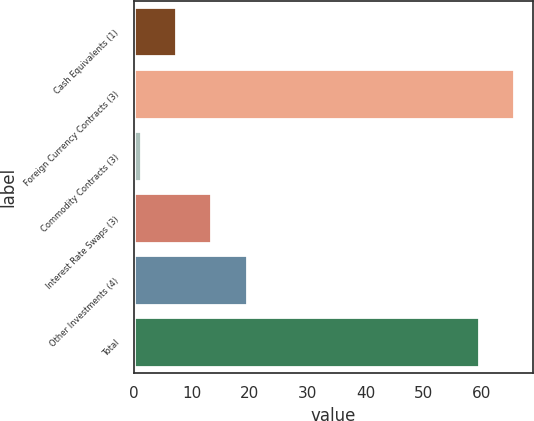Convert chart to OTSL. <chart><loc_0><loc_0><loc_500><loc_500><bar_chart><fcel>Cash Equivalents (1)<fcel>Foreign Currency Contracts (3)<fcel>Commodity Contracts (3)<fcel>Interest Rate Swaps (3)<fcel>Other Investments (4)<fcel>Total<nl><fcel>7.28<fcel>65.58<fcel>1.2<fcel>13.36<fcel>19.44<fcel>59.5<nl></chart> 